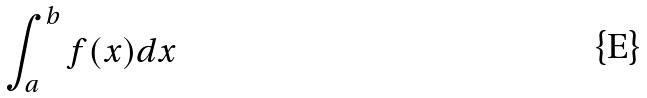<formula> <loc_0><loc_0><loc_500><loc_500>\int _ { a } ^ { b } f ( x ) d x</formula> 